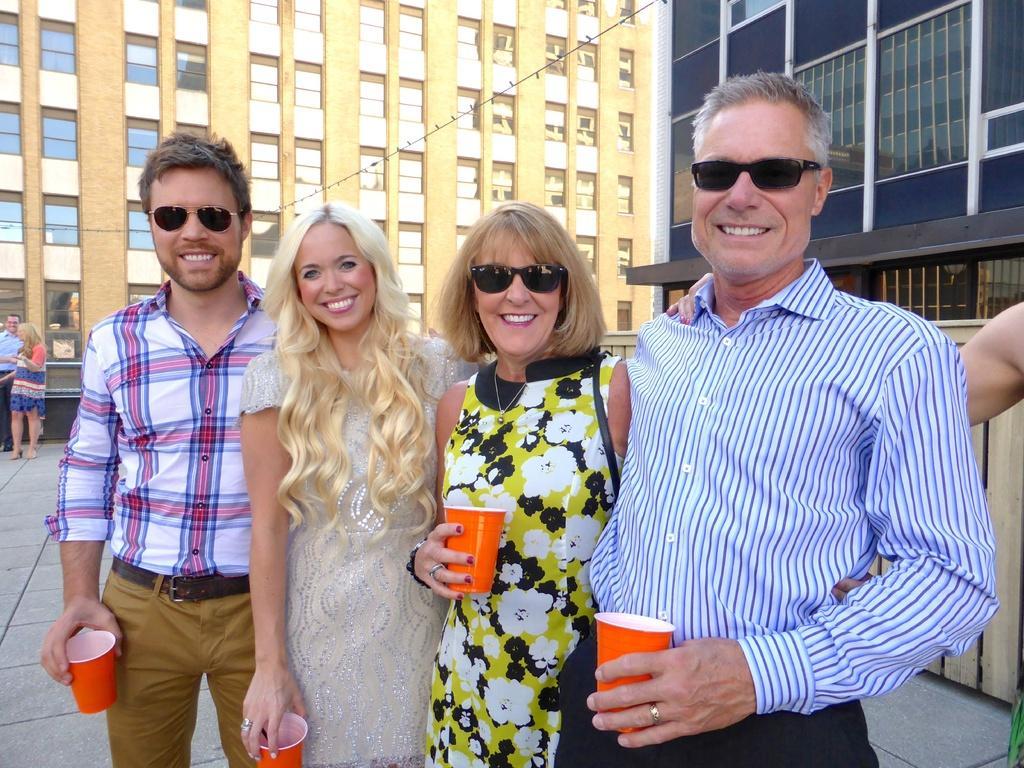In one or two sentences, can you explain what this image depicts? In this picture we can see two men and women wearing black sunglasses standing in the front, holding red glass in the hand, smiling and giving a pose to the camera. Behind there is a yellow building with glass windows. 